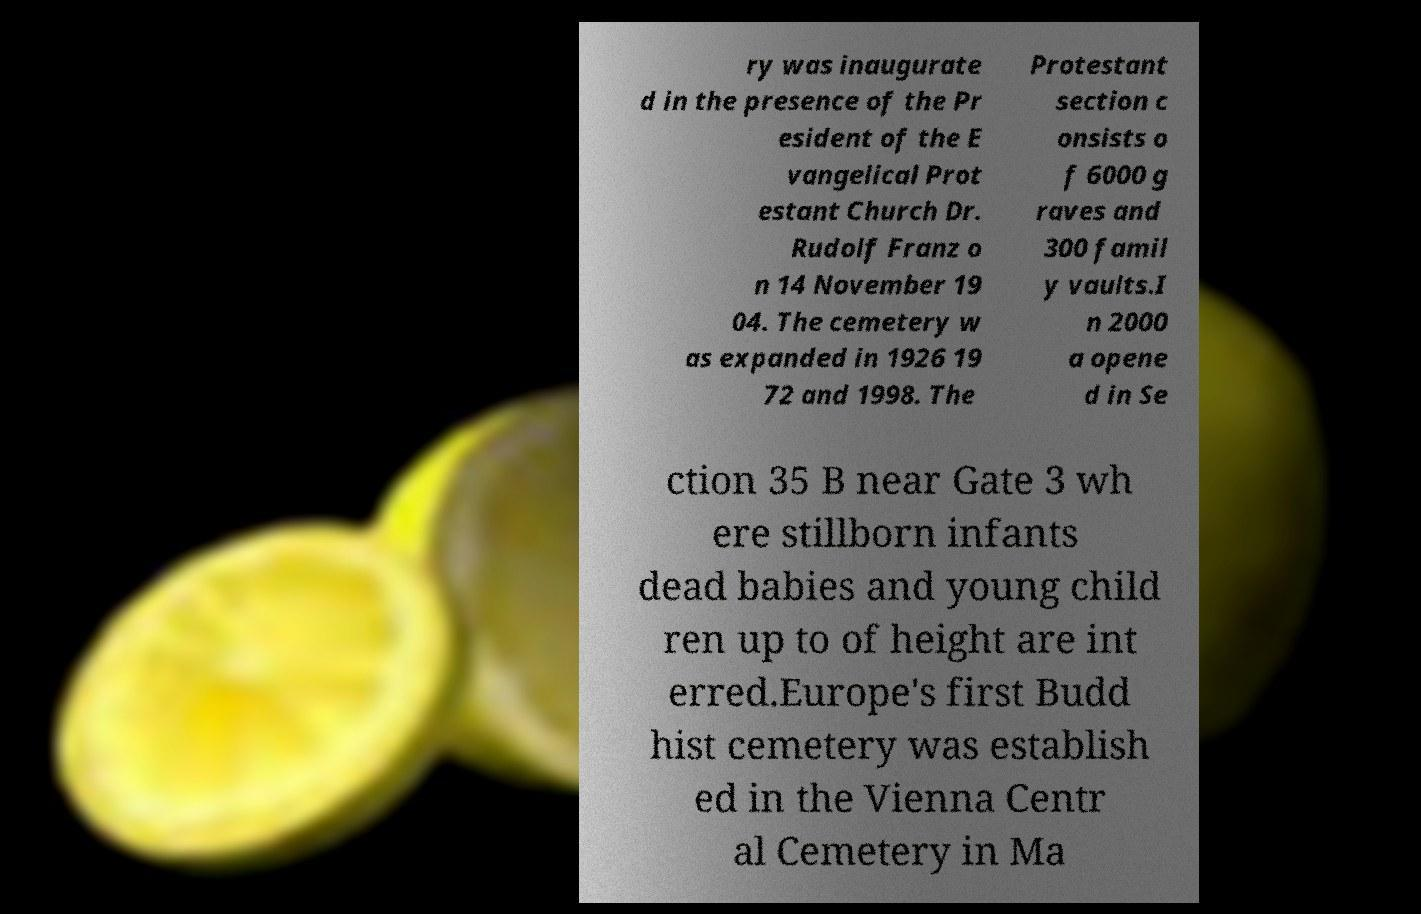I need the written content from this picture converted into text. Can you do that? ry was inaugurate d in the presence of the Pr esident of the E vangelical Prot estant Church Dr. Rudolf Franz o n 14 November 19 04. The cemetery w as expanded in 1926 19 72 and 1998. The Protestant section c onsists o f 6000 g raves and 300 famil y vaults.I n 2000 a opene d in Se ction 35 B near Gate 3 wh ere stillborn infants dead babies and young child ren up to of height are int erred.Europe's first Budd hist cemetery was establish ed in the Vienna Centr al Cemetery in Ma 